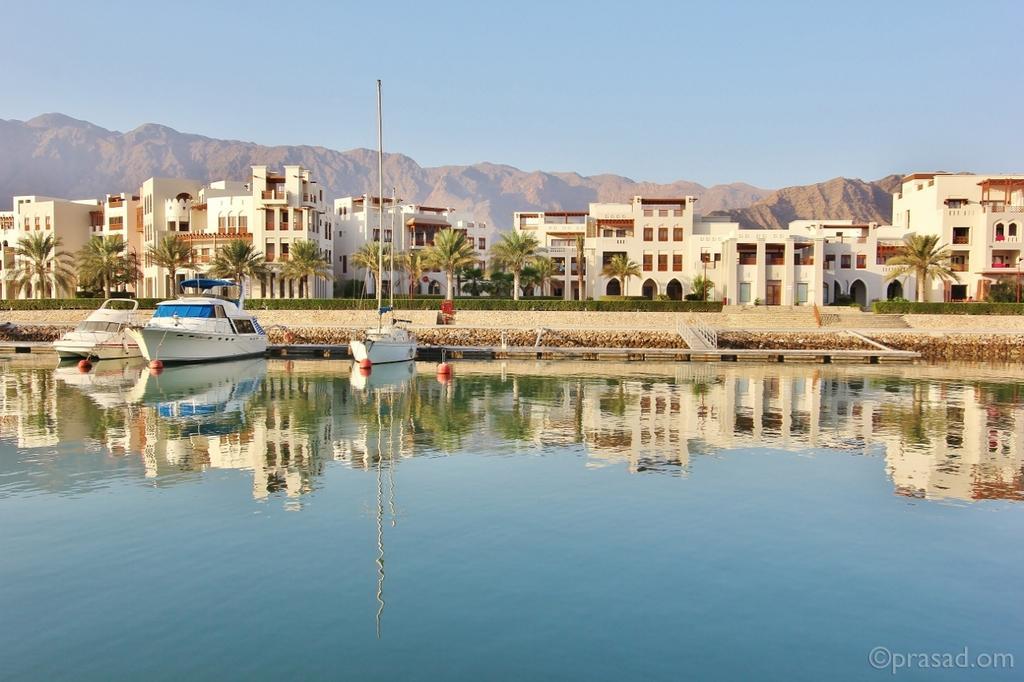Describe this image in one or two sentences. Here there are buildings and trees, there are boats in the water, this sky 